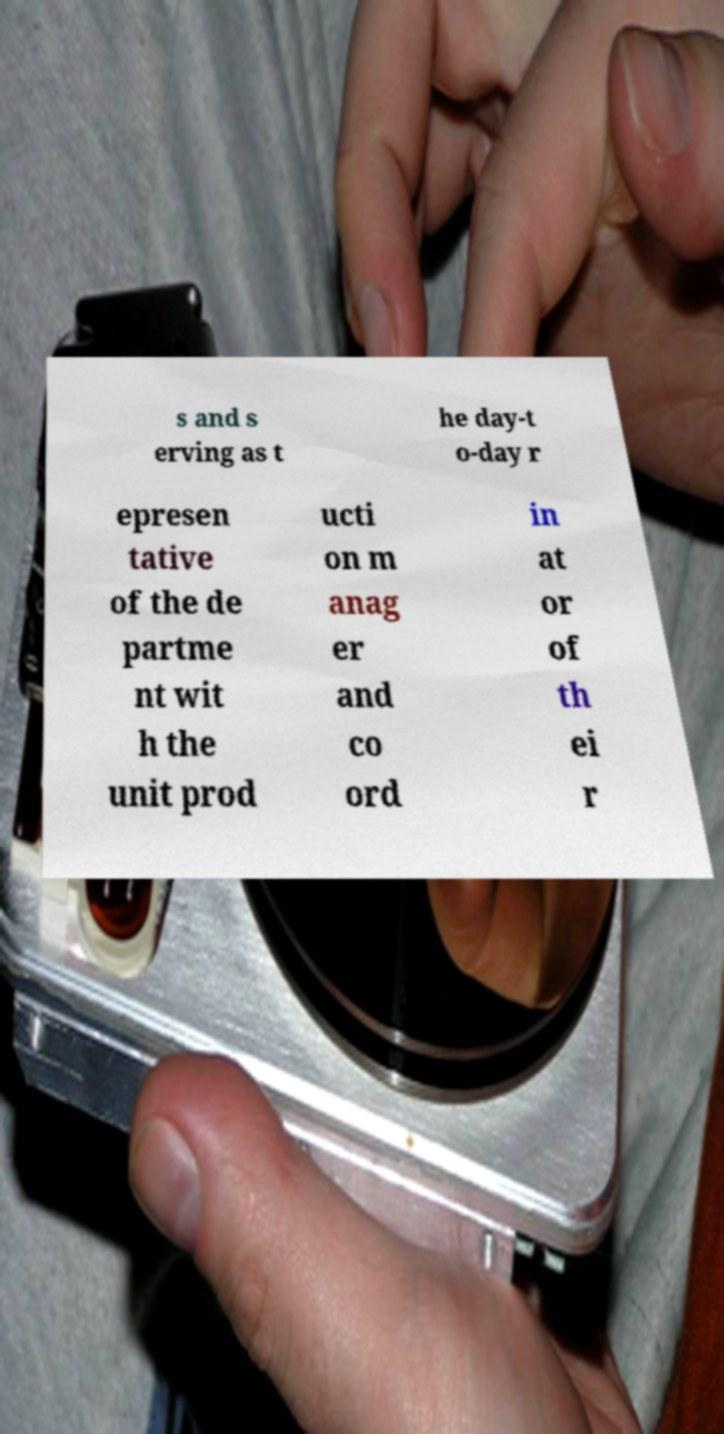For documentation purposes, I need the text within this image transcribed. Could you provide that? s and s erving as t he day-t o-day r epresen tative of the de partme nt wit h the unit prod ucti on m anag er and co ord in at or of th ei r 